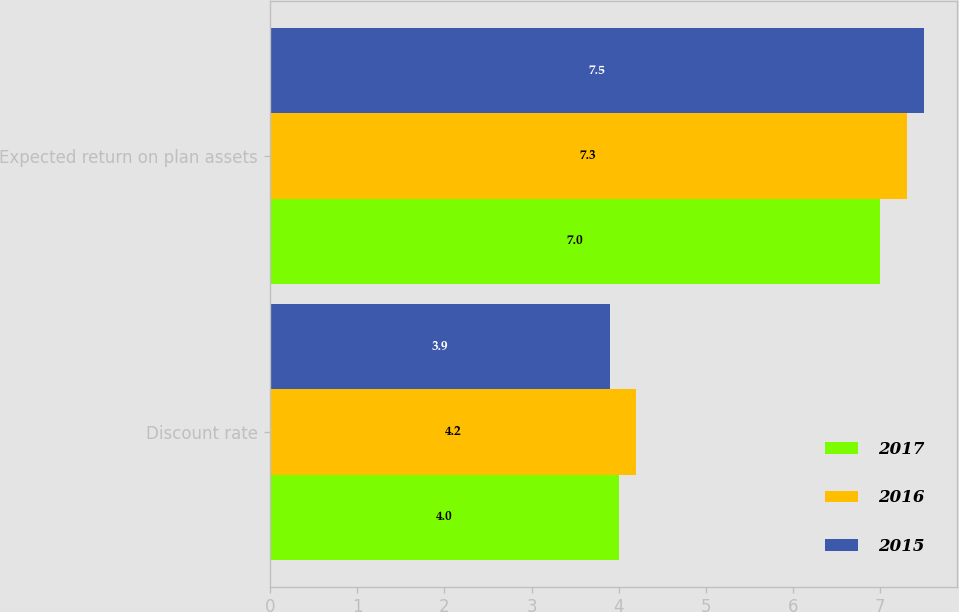Convert chart. <chart><loc_0><loc_0><loc_500><loc_500><stacked_bar_chart><ecel><fcel>Discount rate<fcel>Expected return on plan assets<nl><fcel>2017<fcel>4<fcel>7<nl><fcel>2016<fcel>4.2<fcel>7.3<nl><fcel>2015<fcel>3.9<fcel>7.5<nl></chart> 